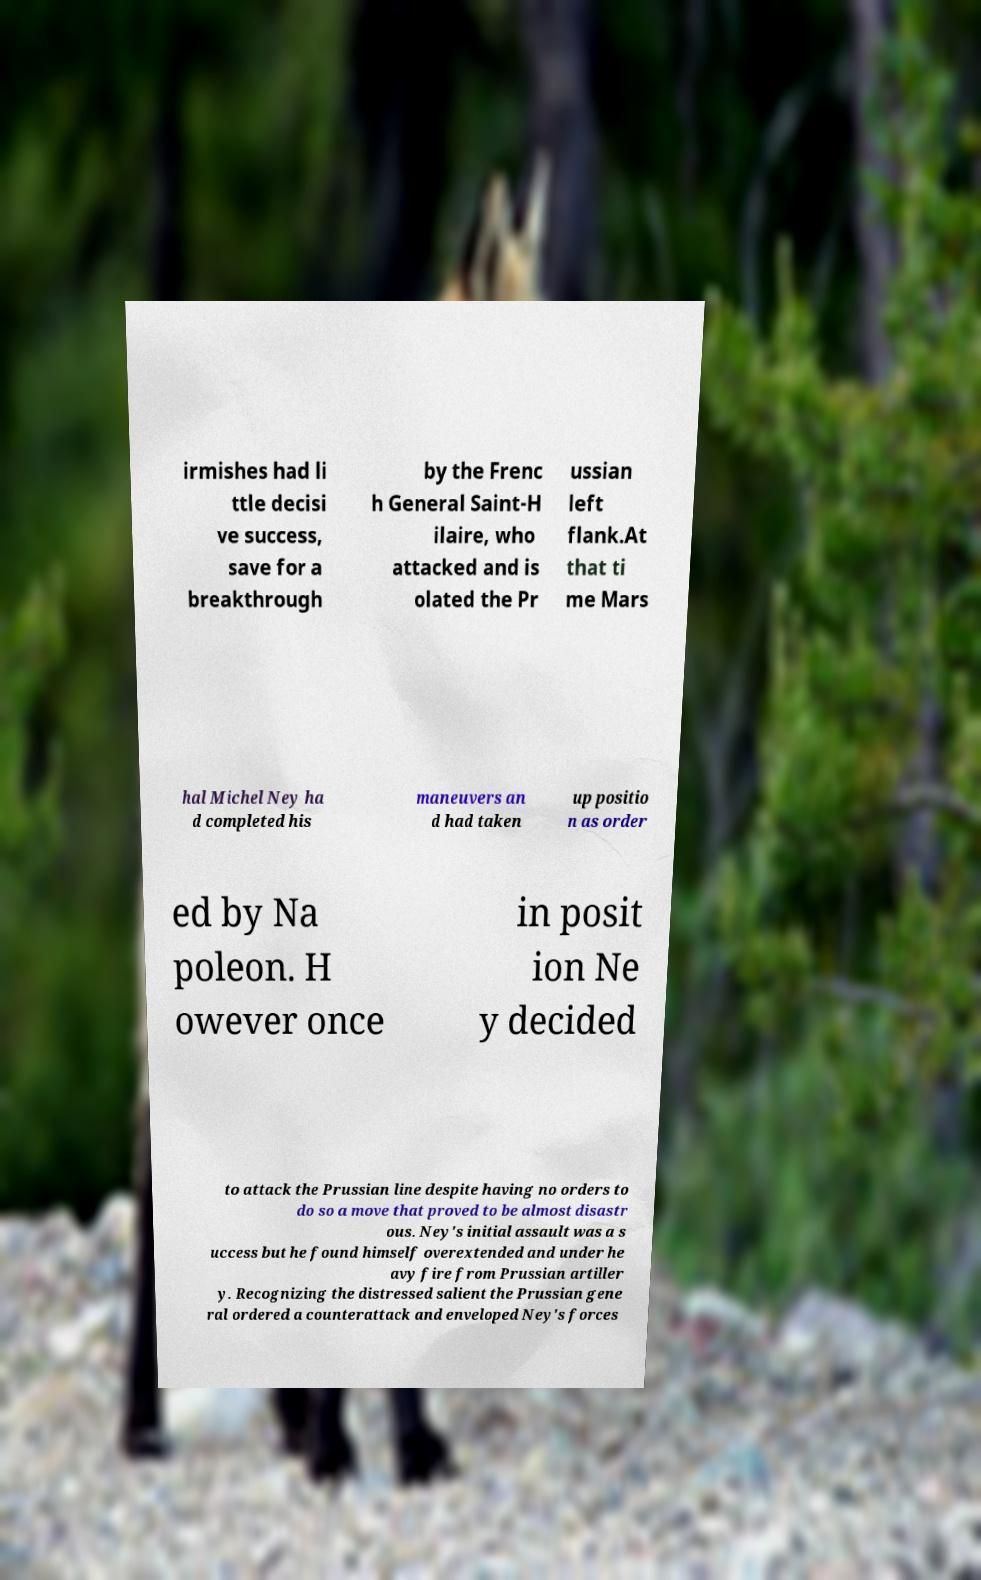Please identify and transcribe the text found in this image. irmishes had li ttle decisi ve success, save for a breakthrough by the Frenc h General Saint-H ilaire, who attacked and is olated the Pr ussian left flank.At that ti me Mars hal Michel Ney ha d completed his maneuvers an d had taken up positio n as order ed by Na poleon. H owever once in posit ion Ne y decided to attack the Prussian line despite having no orders to do so a move that proved to be almost disastr ous. Ney's initial assault was a s uccess but he found himself overextended and under he avy fire from Prussian artiller y. Recognizing the distressed salient the Prussian gene ral ordered a counterattack and enveloped Ney's forces 